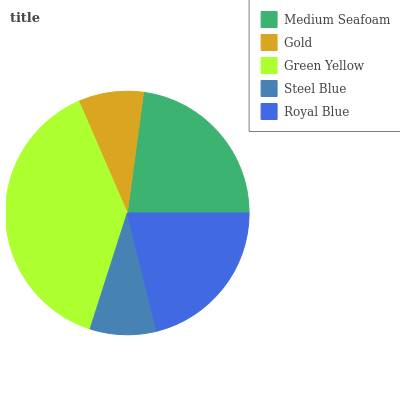Is Gold the minimum?
Answer yes or no. Yes. Is Green Yellow the maximum?
Answer yes or no. Yes. Is Green Yellow the minimum?
Answer yes or no. No. Is Gold the maximum?
Answer yes or no. No. Is Green Yellow greater than Gold?
Answer yes or no. Yes. Is Gold less than Green Yellow?
Answer yes or no. Yes. Is Gold greater than Green Yellow?
Answer yes or no. No. Is Green Yellow less than Gold?
Answer yes or no. No. Is Royal Blue the high median?
Answer yes or no. Yes. Is Royal Blue the low median?
Answer yes or no. Yes. Is Green Yellow the high median?
Answer yes or no. No. Is Steel Blue the low median?
Answer yes or no. No. 